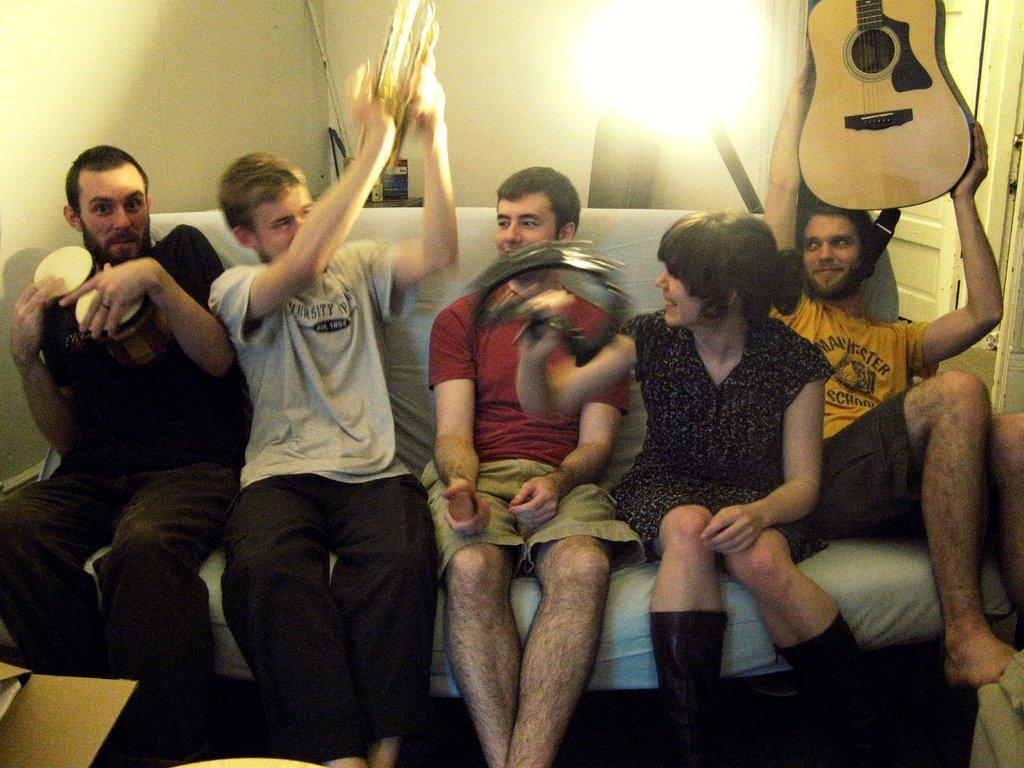Describe this image in one or two sentences. In this image i can see a group of people who are sitting on a couch. The person on the right side is holding a guitar in his hands. 